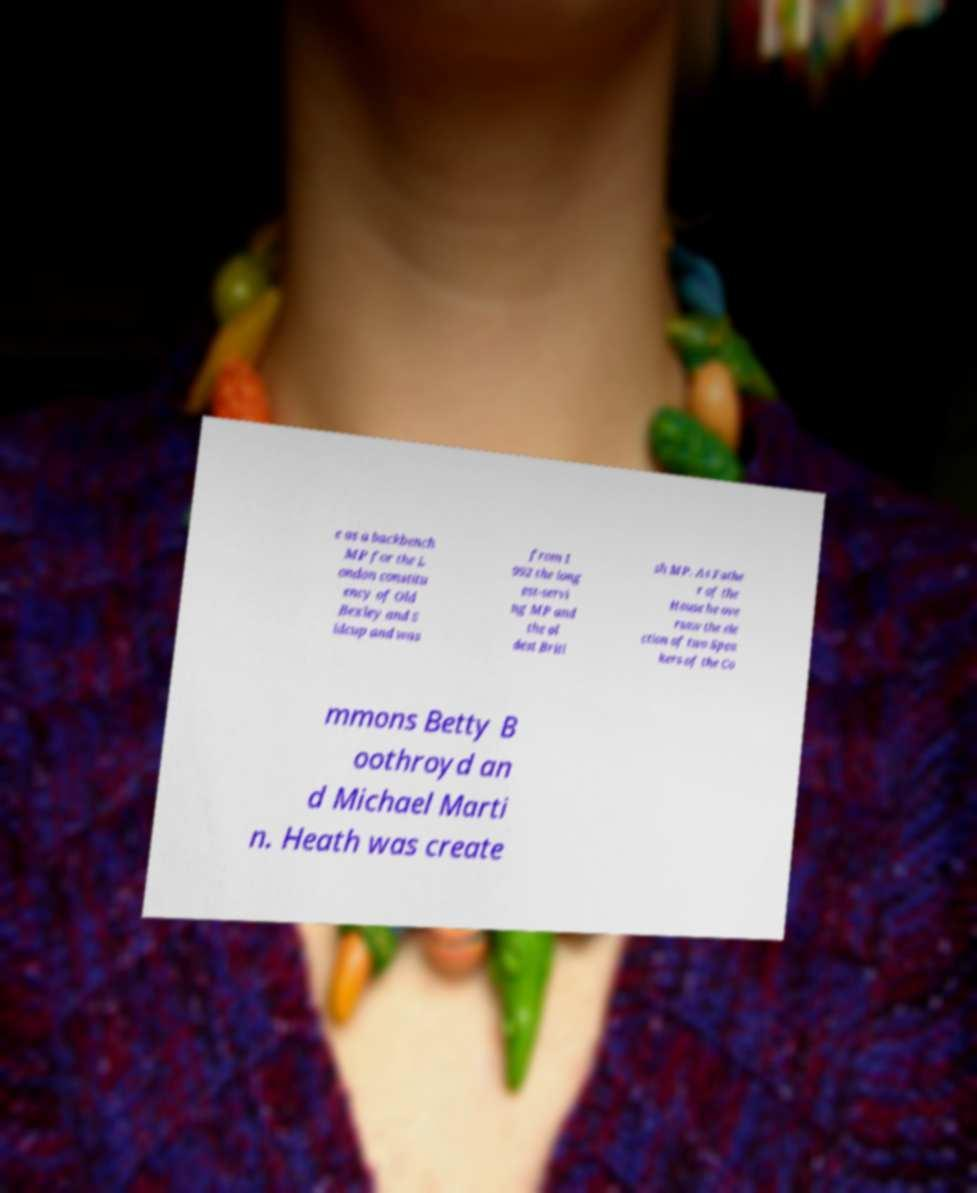Please read and relay the text visible in this image. What does it say? e as a backbench MP for the L ondon constitu ency of Old Bexley and S idcup and was from 1 992 the long est-servi ng MP and the ol dest Briti sh MP. As Fathe r of the House he ove rsaw the ele ction of two Spea kers of the Co mmons Betty B oothroyd an d Michael Marti n. Heath was create 